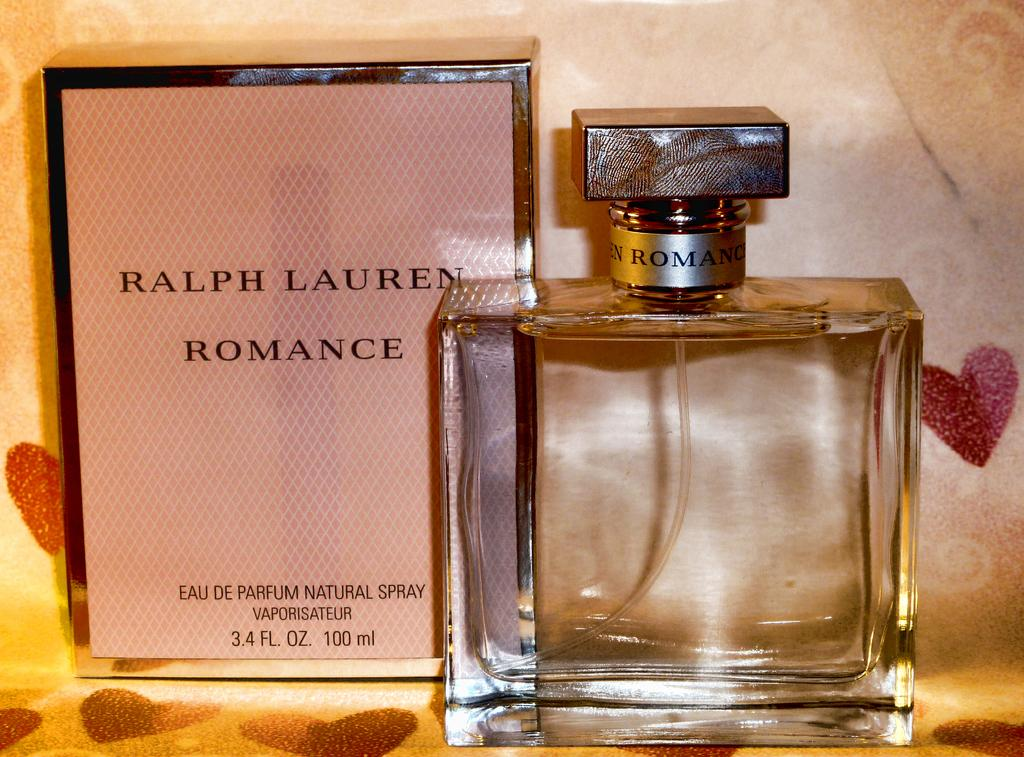Provide a one-sentence caption for the provided image. A square bottle of Ralph Lauren Romance perfume next to its box. 